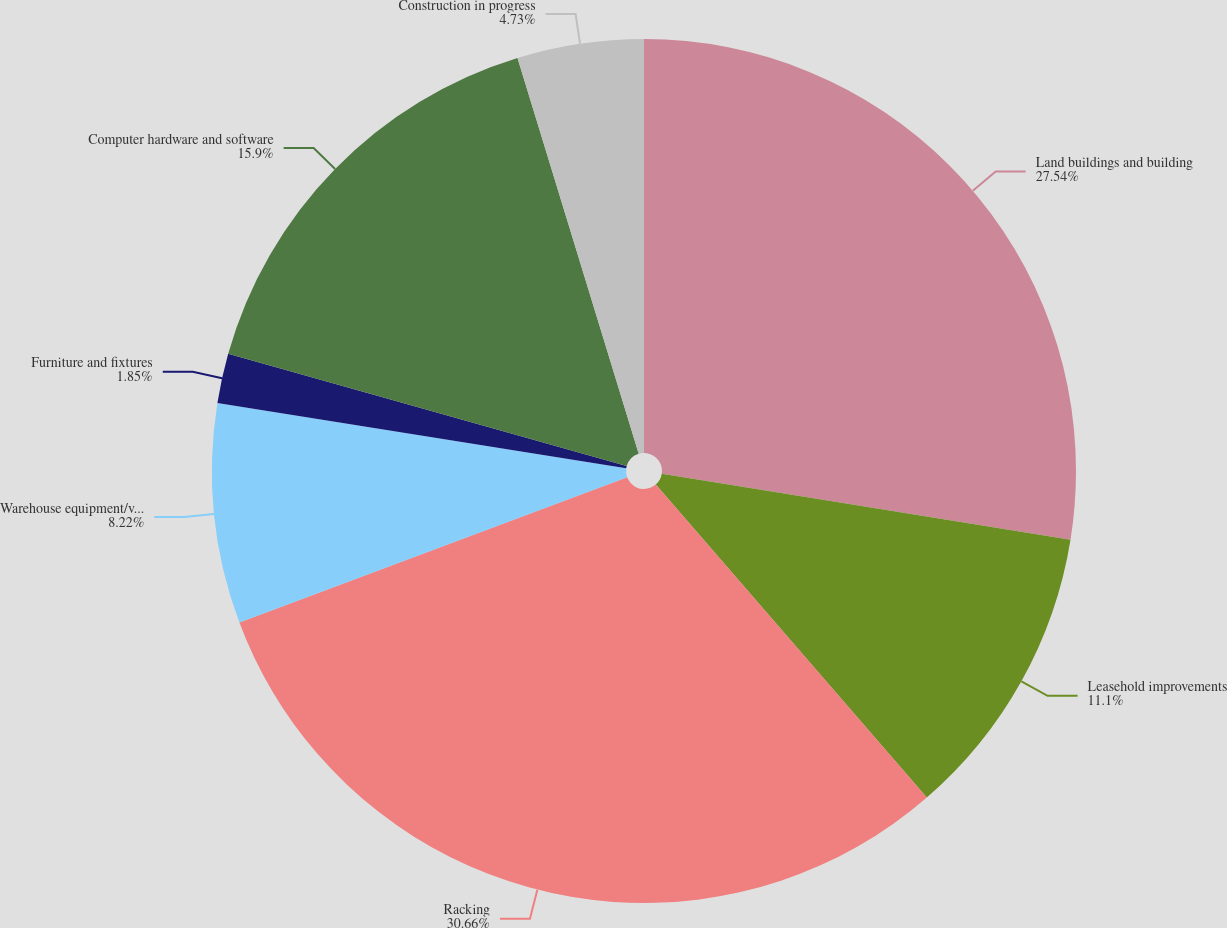Convert chart to OTSL. <chart><loc_0><loc_0><loc_500><loc_500><pie_chart><fcel>Land buildings and building<fcel>Leasehold improvements<fcel>Racking<fcel>Warehouse equipment/vehicles<fcel>Furniture and fixtures<fcel>Computer hardware and software<fcel>Construction in progress<nl><fcel>27.54%<fcel>11.1%<fcel>30.66%<fcel>8.22%<fcel>1.85%<fcel>15.9%<fcel>4.73%<nl></chart> 